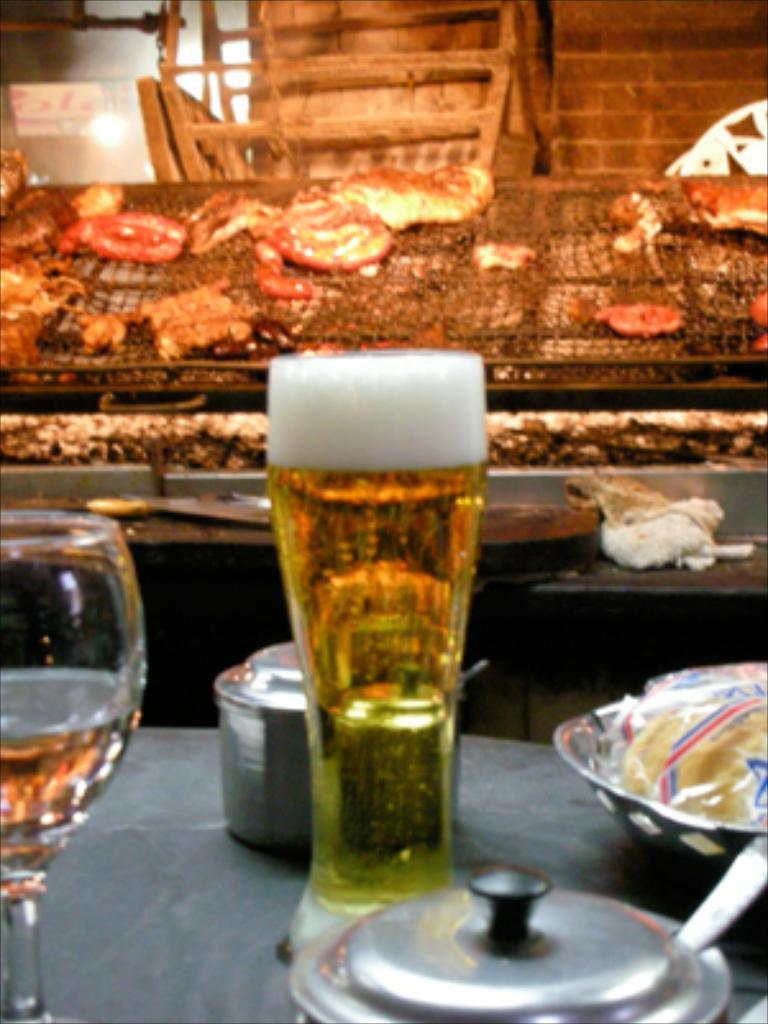What is on the table in the image? There is a bowl, glasses with liquid, and a container on the table. Can you describe the contents of the bowl? The contents of the bowl are not specified in the image. What is inside the glasses on the table? The glasses on the table contain liquid. What else can be seen on the table besides the bowl, glasses, and container? There are unspecified objects on the table. Is there a snake slithering across the table in the image? No, there is no snake present in the image. 